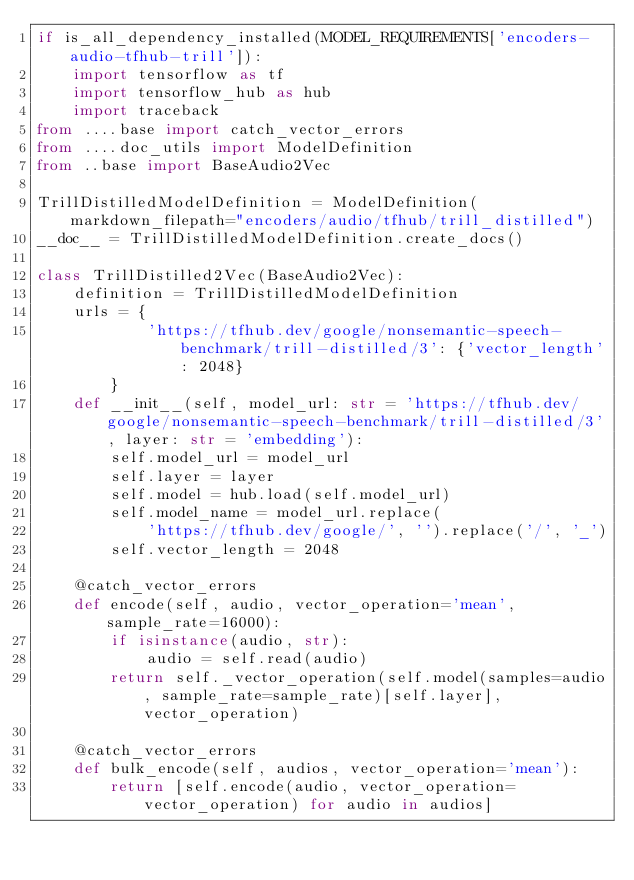<code> <loc_0><loc_0><loc_500><loc_500><_Python_>if is_all_dependency_installed(MODEL_REQUIREMENTS['encoders-audio-tfhub-trill']):
    import tensorflow as tf
    import tensorflow_hub as hub
    import traceback
from ....base import catch_vector_errors
from ....doc_utils import ModelDefinition
from ..base import BaseAudio2Vec

TrillDistilledModelDefinition = ModelDefinition(markdown_filepath="encoders/audio/tfhub/trill_distilled")
__doc__ = TrillDistilledModelDefinition.create_docs()

class TrillDistilled2Vec(BaseAudio2Vec):
    definition = TrillDistilledModelDefinition
    urls = {
            'https://tfhub.dev/google/nonsemantic-speech-benchmark/trill-distilled/3': {'vector_length': 2048}
        }
    def __init__(self, model_url: str = 'https://tfhub.dev/google/nonsemantic-speech-benchmark/trill-distilled/3', layer: str = 'embedding'):
        self.model_url = model_url
        self.layer = layer
        self.model = hub.load(self.model_url)
        self.model_name = model_url.replace(
            'https://tfhub.dev/google/', '').replace('/', '_')
        self.vector_length = 2048

    @catch_vector_errors
    def encode(self, audio, vector_operation='mean', sample_rate=16000):
        if isinstance(audio, str):
            audio = self.read(audio)
        return self._vector_operation(self.model(samples=audio, sample_rate=sample_rate)[self.layer], vector_operation)
    
    @catch_vector_errors
    def bulk_encode(self, audios, vector_operation='mean'):
        return [self.encode(audio, vector_operation=vector_operation) for audio in audios]
</code> 